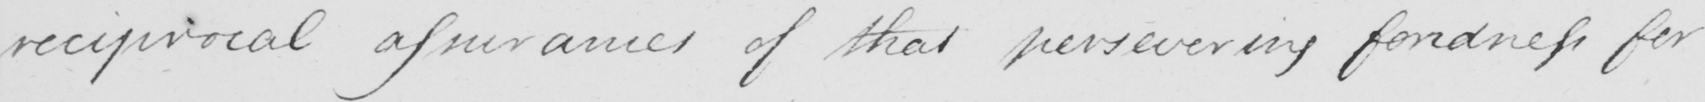What is written in this line of handwriting? reciprocal assurances of that persevering fondness for 